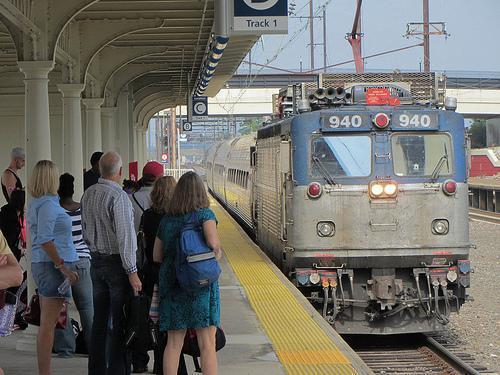How many trains are there?
Give a very brief answer. 1. 